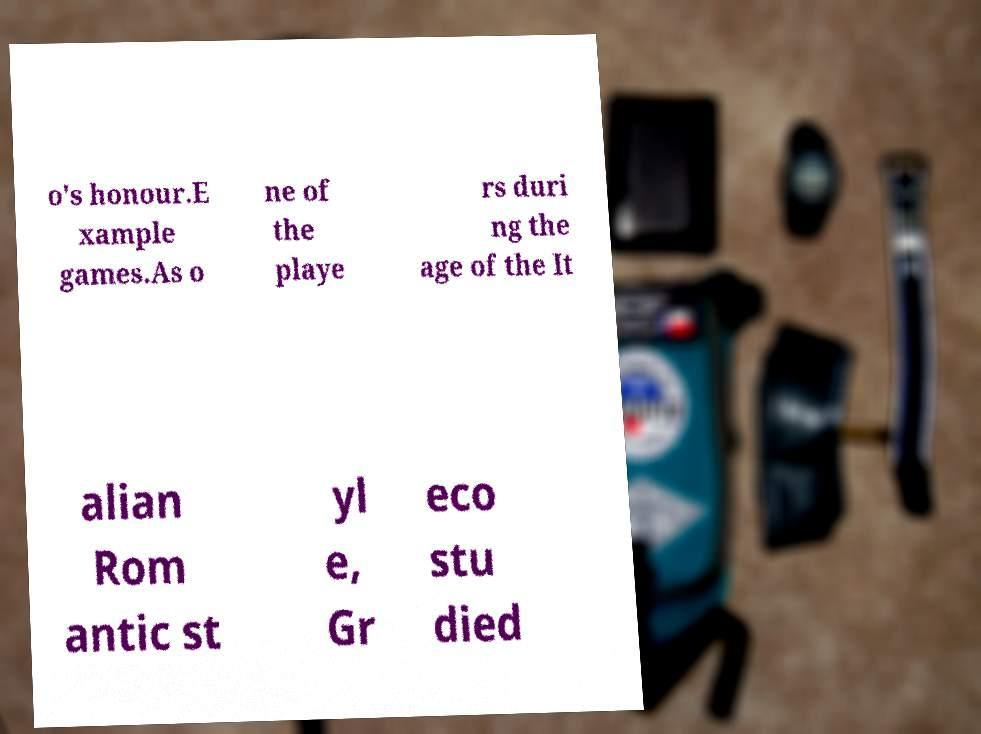What messages or text are displayed in this image? I need them in a readable, typed format. o's honour.E xample games.As o ne of the playe rs duri ng the age of the It alian Rom antic st yl e, Gr eco stu died 